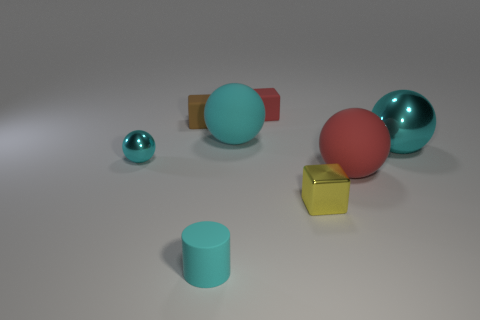Subtract all cyan balls. How many were subtracted if there are1cyan balls left? 2 Subtract all tiny rubber blocks. How many blocks are left? 1 Subtract all blocks. How many objects are left? 5 Add 2 small blue matte cubes. How many objects exist? 10 Subtract 3 blocks. How many blocks are left? 0 Add 2 tiny cyan shiny objects. How many tiny cyan shiny objects are left? 3 Add 6 large brown cylinders. How many large brown cylinders exist? 6 Subtract all red cubes. How many cubes are left? 2 Subtract 0 yellow cylinders. How many objects are left? 8 Subtract all green balls. Subtract all purple cylinders. How many balls are left? 4 